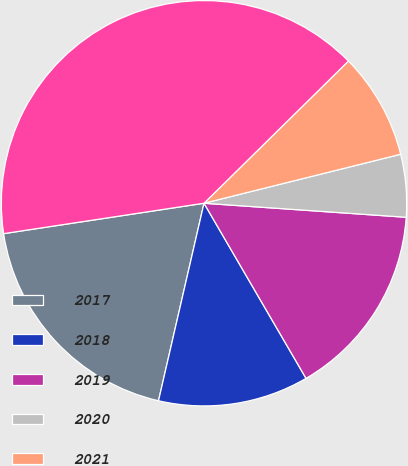Convert chart to OTSL. <chart><loc_0><loc_0><loc_500><loc_500><pie_chart><fcel>2017<fcel>2018<fcel>2019<fcel>2020<fcel>2021<fcel>Thereafter<nl><fcel>19.0%<fcel>12.0%<fcel>15.5%<fcel>4.99%<fcel>8.49%<fcel>40.02%<nl></chart> 